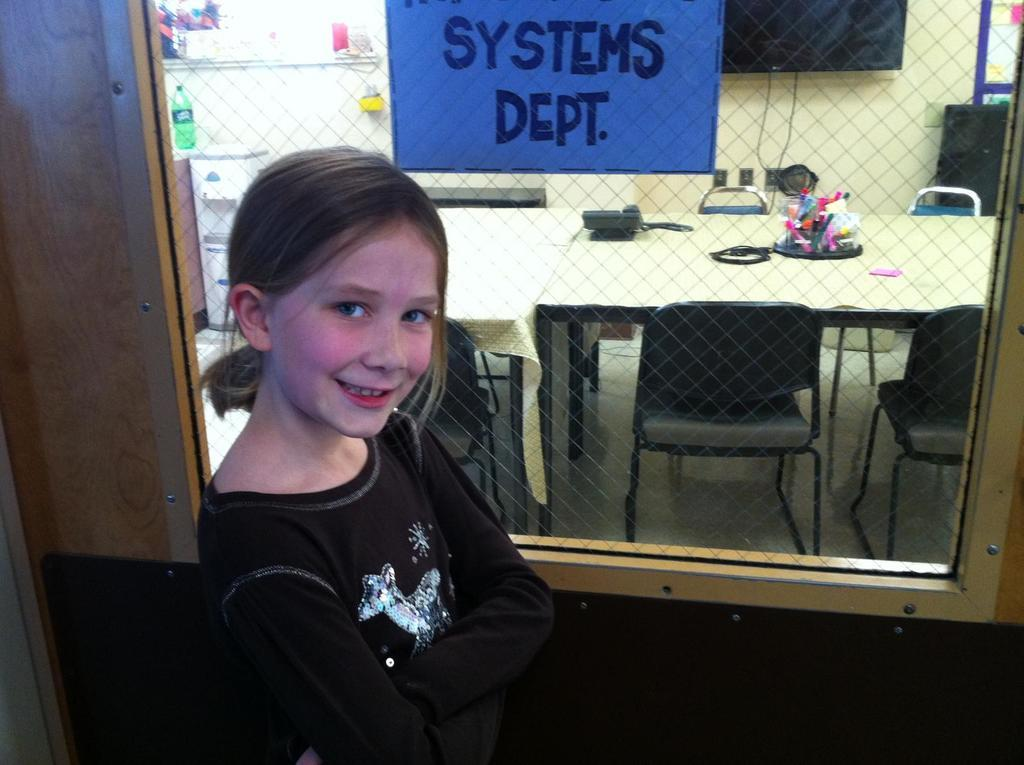What is the main subject of the image? The main subject of the image is a kid. What is the kid doing in the image? The kid is standing in front of a system. What can be seen in the background of the image? There are chairs, tables, and a television in the background of the image. How many girls are present in the image? The image does not show any girls; it features a kid who is likely a boy, based on the provided facts. 